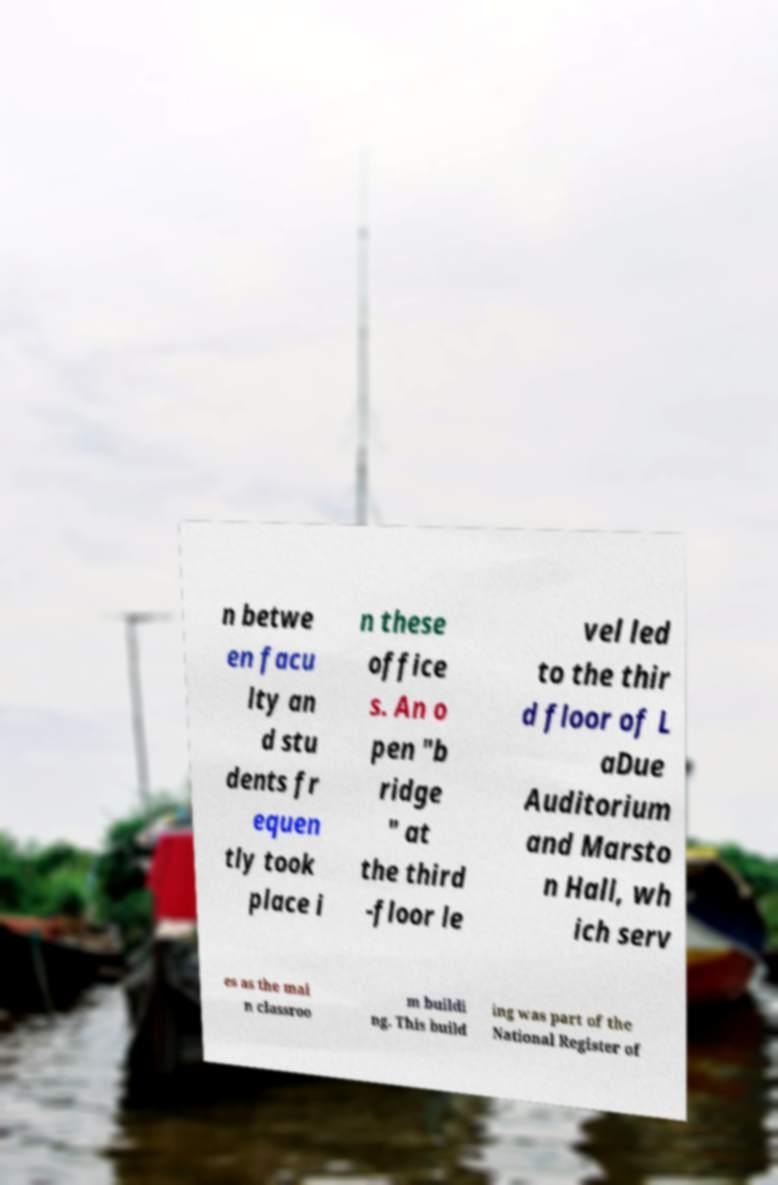Could you assist in decoding the text presented in this image and type it out clearly? n betwe en facu lty an d stu dents fr equen tly took place i n these office s. An o pen "b ridge " at the third -floor le vel led to the thir d floor of L aDue Auditorium and Marsto n Hall, wh ich serv es as the mai n classroo m buildi ng. This build ing was part of the National Register of 